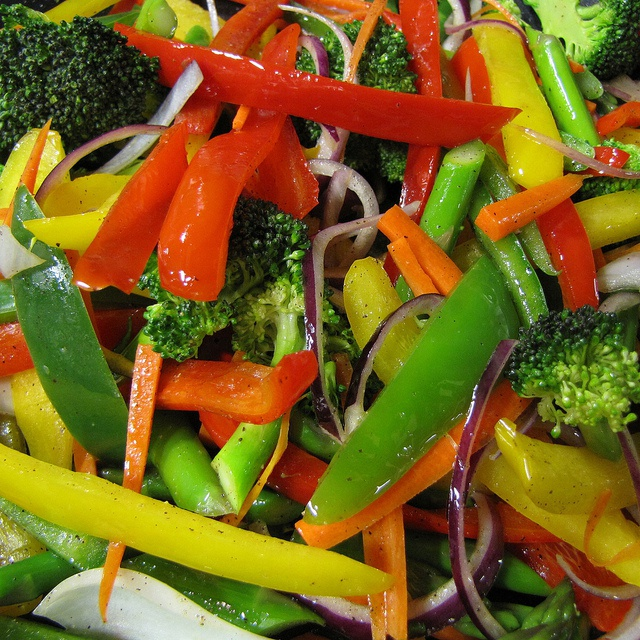Describe the objects in this image and their specific colors. I can see broccoli in black, darkgreen, and olive tones, carrot in black, brown, red, and maroon tones, broccoli in black and darkgreen tones, carrot in black, red, and brown tones, and broccoli in black, darkgreen, and olive tones in this image. 